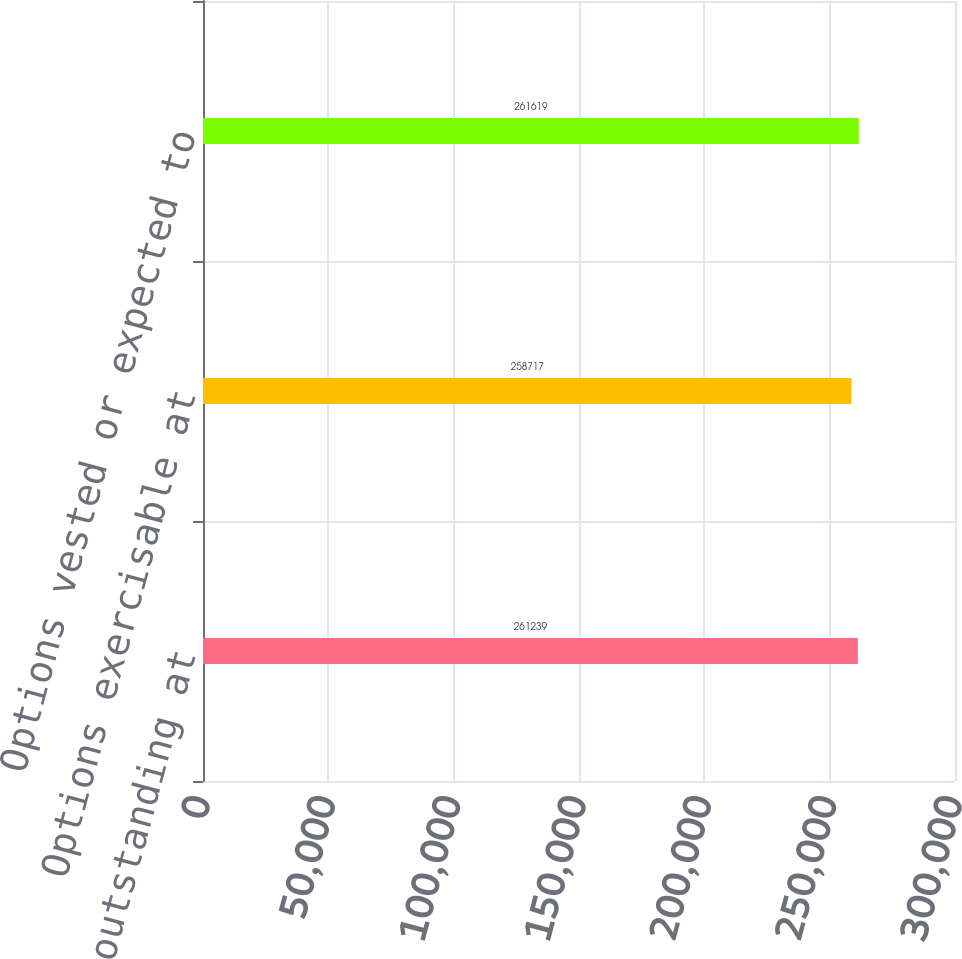Convert chart. <chart><loc_0><loc_0><loc_500><loc_500><bar_chart><fcel>Options outstanding at<fcel>Options exercisable at<fcel>Options vested or expected to<nl><fcel>261239<fcel>258717<fcel>261619<nl></chart> 